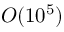<formula> <loc_0><loc_0><loc_500><loc_500>O ( 1 0 ^ { 5 } )</formula> 